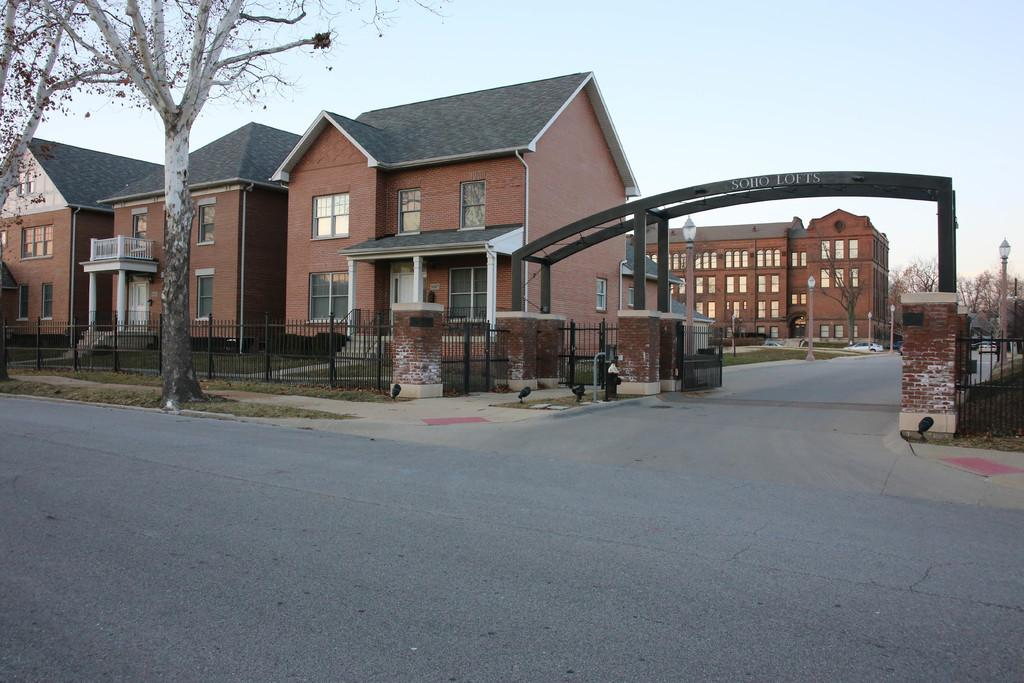What type of structures can be seen in the image? There are houses in the image. What architectural feature is present in the image? There is an arch in the image. What type of vegetation is visible in the image? There are trees and plants in the image. What type of barrier is present beside the road in the image? There is fencing beside the road in the image. What type of animals can be seen in the zoo in the image? There is no zoo present in the image; it features houses, an arch, trees, plants, and fencing beside the road. What decisions were made by the committee in the image? There is no committee present in the image. 